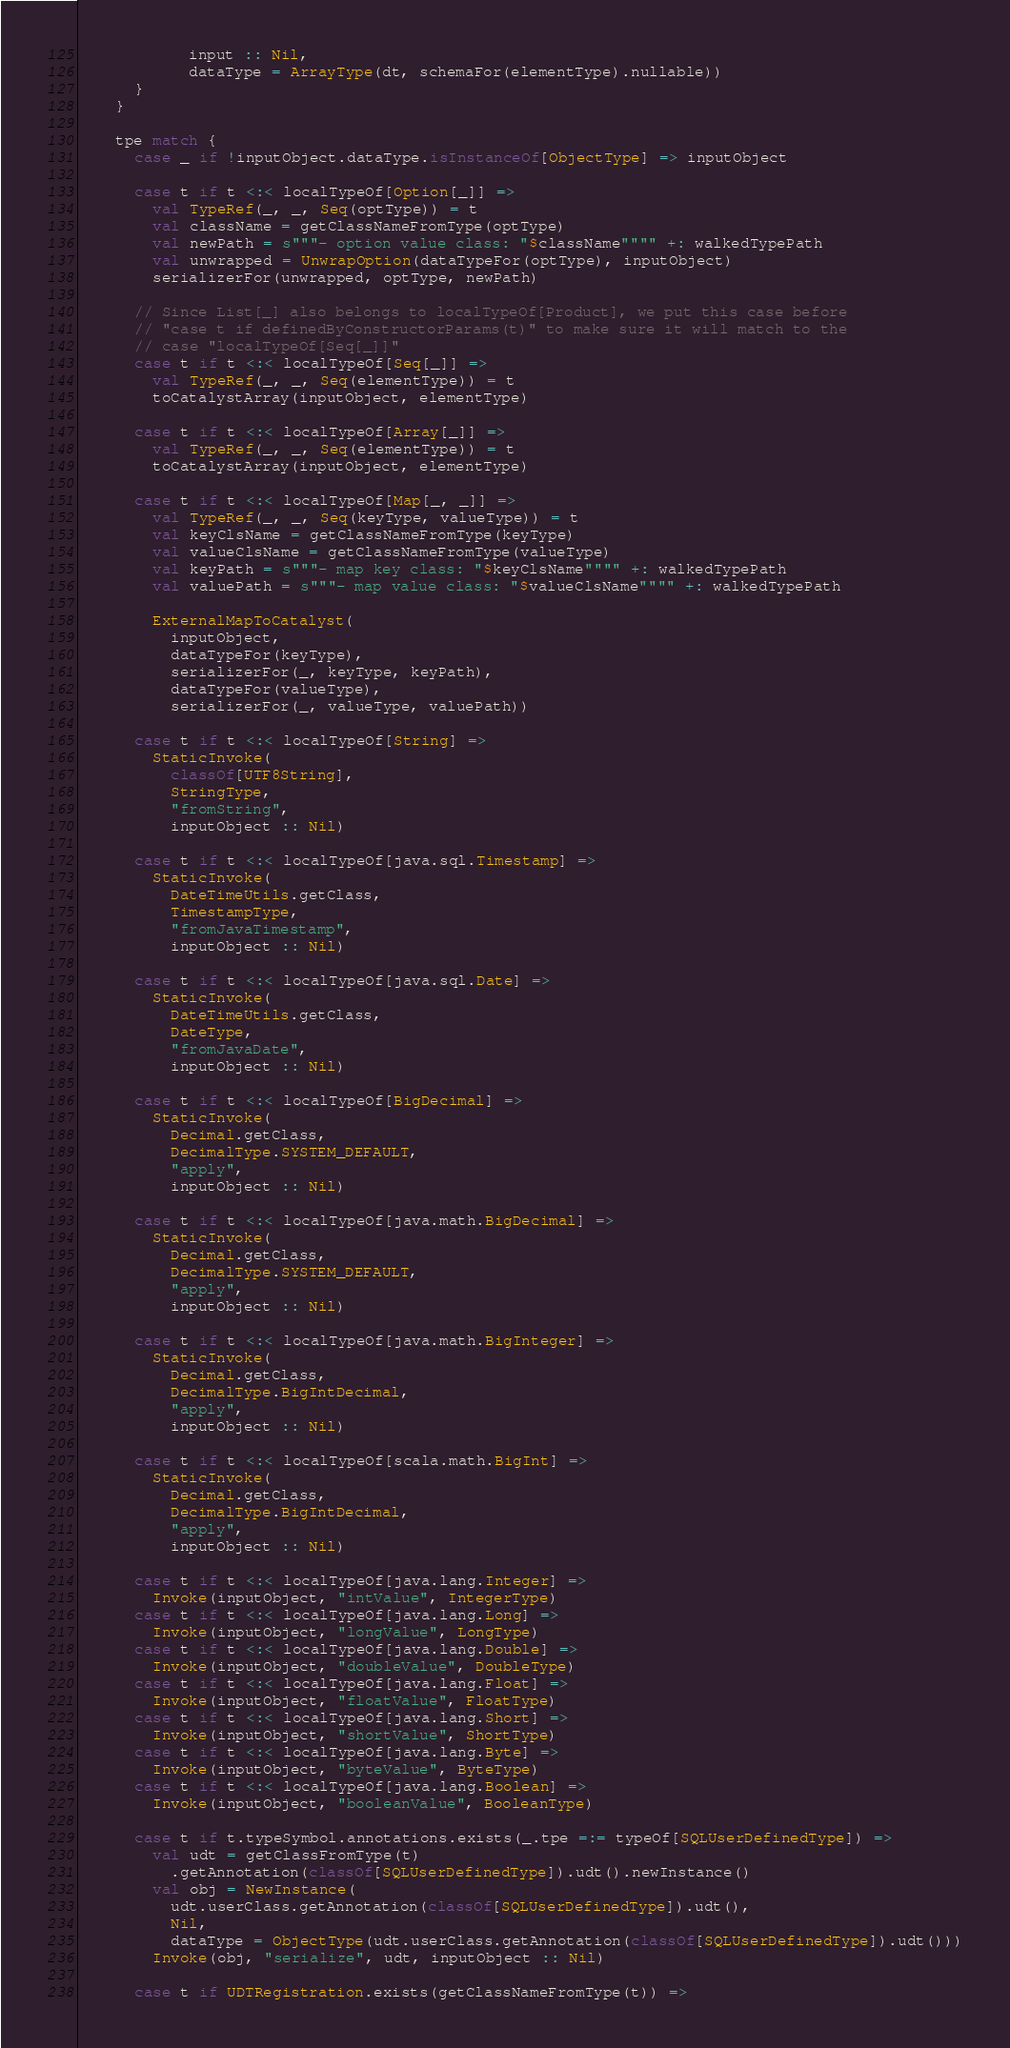<code> <loc_0><loc_0><loc_500><loc_500><_Scala_>            input :: Nil,
            dataType = ArrayType(dt, schemaFor(elementType).nullable))
      }
    }

    tpe match {
      case _ if !inputObject.dataType.isInstanceOf[ObjectType] => inputObject

      case t if t <:< localTypeOf[Option[_]] =>
        val TypeRef(_, _, Seq(optType)) = t
        val className = getClassNameFromType(optType)
        val newPath = s"""- option value class: "$className"""" +: walkedTypePath
        val unwrapped = UnwrapOption(dataTypeFor(optType), inputObject)
        serializerFor(unwrapped, optType, newPath)

      // Since List[_] also belongs to localTypeOf[Product], we put this case before
      // "case t if definedByConstructorParams(t)" to make sure it will match to the
      // case "localTypeOf[Seq[_]]"
      case t if t <:< localTypeOf[Seq[_]] =>
        val TypeRef(_, _, Seq(elementType)) = t
        toCatalystArray(inputObject, elementType)

      case t if t <:< localTypeOf[Array[_]] =>
        val TypeRef(_, _, Seq(elementType)) = t
        toCatalystArray(inputObject, elementType)

      case t if t <:< localTypeOf[Map[_, _]] =>
        val TypeRef(_, _, Seq(keyType, valueType)) = t
        val keyClsName = getClassNameFromType(keyType)
        val valueClsName = getClassNameFromType(valueType)
        val keyPath = s"""- map key class: "$keyClsName"""" +: walkedTypePath
        val valuePath = s"""- map value class: "$valueClsName"""" +: walkedTypePath

        ExternalMapToCatalyst(
          inputObject,
          dataTypeFor(keyType),
          serializerFor(_, keyType, keyPath),
          dataTypeFor(valueType),
          serializerFor(_, valueType, valuePath))

      case t if t <:< localTypeOf[String] =>
        StaticInvoke(
          classOf[UTF8String],
          StringType,
          "fromString",
          inputObject :: Nil)

      case t if t <:< localTypeOf[java.sql.Timestamp] =>
        StaticInvoke(
          DateTimeUtils.getClass,
          TimestampType,
          "fromJavaTimestamp",
          inputObject :: Nil)

      case t if t <:< localTypeOf[java.sql.Date] =>
        StaticInvoke(
          DateTimeUtils.getClass,
          DateType,
          "fromJavaDate",
          inputObject :: Nil)

      case t if t <:< localTypeOf[BigDecimal] =>
        StaticInvoke(
          Decimal.getClass,
          DecimalType.SYSTEM_DEFAULT,
          "apply",
          inputObject :: Nil)

      case t if t <:< localTypeOf[java.math.BigDecimal] =>
        StaticInvoke(
          Decimal.getClass,
          DecimalType.SYSTEM_DEFAULT,
          "apply",
          inputObject :: Nil)

      case t if t <:< localTypeOf[java.math.BigInteger] =>
        StaticInvoke(
          Decimal.getClass,
          DecimalType.BigIntDecimal,
          "apply",
          inputObject :: Nil)

      case t if t <:< localTypeOf[scala.math.BigInt] =>
        StaticInvoke(
          Decimal.getClass,
          DecimalType.BigIntDecimal,
          "apply",
          inputObject :: Nil)

      case t if t <:< localTypeOf[java.lang.Integer] =>
        Invoke(inputObject, "intValue", IntegerType)
      case t if t <:< localTypeOf[java.lang.Long] =>
        Invoke(inputObject, "longValue", LongType)
      case t if t <:< localTypeOf[java.lang.Double] =>
        Invoke(inputObject, "doubleValue", DoubleType)
      case t if t <:< localTypeOf[java.lang.Float] =>
        Invoke(inputObject, "floatValue", FloatType)
      case t if t <:< localTypeOf[java.lang.Short] =>
        Invoke(inputObject, "shortValue", ShortType)
      case t if t <:< localTypeOf[java.lang.Byte] =>
        Invoke(inputObject, "byteValue", ByteType)
      case t if t <:< localTypeOf[java.lang.Boolean] =>
        Invoke(inputObject, "booleanValue", BooleanType)

      case t if t.typeSymbol.annotations.exists(_.tpe =:= typeOf[SQLUserDefinedType]) =>
        val udt = getClassFromType(t)
          .getAnnotation(classOf[SQLUserDefinedType]).udt().newInstance()
        val obj = NewInstance(
          udt.userClass.getAnnotation(classOf[SQLUserDefinedType]).udt(),
          Nil,
          dataType = ObjectType(udt.userClass.getAnnotation(classOf[SQLUserDefinedType]).udt()))
        Invoke(obj, "serialize", udt, inputObject :: Nil)

      case t if UDTRegistration.exists(getClassNameFromType(t)) =></code> 